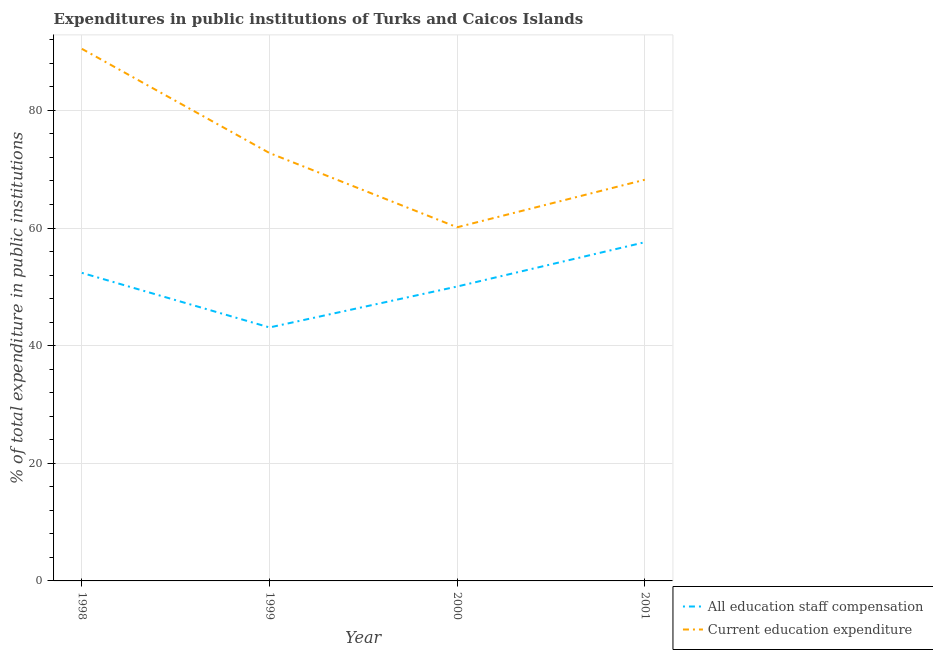How many different coloured lines are there?
Offer a terse response. 2. Is the number of lines equal to the number of legend labels?
Make the answer very short. Yes. What is the expenditure in staff compensation in 2000?
Provide a short and direct response. 50.06. Across all years, what is the maximum expenditure in education?
Provide a short and direct response. 90.48. Across all years, what is the minimum expenditure in education?
Offer a very short reply. 60.13. What is the total expenditure in staff compensation in the graph?
Make the answer very short. 203.12. What is the difference between the expenditure in staff compensation in 1998 and that in 2000?
Provide a short and direct response. 2.32. What is the difference between the expenditure in education in 1998 and the expenditure in staff compensation in 2000?
Keep it short and to the point. 40.42. What is the average expenditure in education per year?
Your response must be concise. 72.89. In the year 1998, what is the difference between the expenditure in staff compensation and expenditure in education?
Provide a succinct answer. -38.1. In how many years, is the expenditure in staff compensation greater than 28 %?
Your answer should be compact. 4. What is the ratio of the expenditure in staff compensation in 1998 to that in 1999?
Your answer should be very brief. 1.22. What is the difference between the highest and the second highest expenditure in staff compensation?
Offer a terse response. 5.21. What is the difference between the highest and the lowest expenditure in education?
Your answer should be very brief. 30.35. In how many years, is the expenditure in staff compensation greater than the average expenditure in staff compensation taken over all years?
Keep it short and to the point. 2. Is the sum of the expenditure in staff compensation in 2000 and 2001 greater than the maximum expenditure in education across all years?
Offer a terse response. Yes. Is the expenditure in education strictly greater than the expenditure in staff compensation over the years?
Offer a very short reply. Yes. Is the expenditure in education strictly less than the expenditure in staff compensation over the years?
Your answer should be very brief. No. How many lines are there?
Provide a short and direct response. 2. How many years are there in the graph?
Ensure brevity in your answer.  4. Are the values on the major ticks of Y-axis written in scientific E-notation?
Provide a short and direct response. No. Where does the legend appear in the graph?
Offer a terse response. Bottom right. How are the legend labels stacked?
Provide a short and direct response. Vertical. What is the title of the graph?
Your answer should be compact. Expenditures in public institutions of Turks and Caicos Islands. Does "Enforce a contract" appear as one of the legend labels in the graph?
Ensure brevity in your answer.  No. What is the label or title of the Y-axis?
Provide a short and direct response. % of total expenditure in public institutions. What is the % of total expenditure in public institutions of All education staff compensation in 1998?
Your answer should be compact. 52.38. What is the % of total expenditure in public institutions in Current education expenditure in 1998?
Your response must be concise. 90.48. What is the % of total expenditure in public institutions in All education staff compensation in 1999?
Provide a short and direct response. 43.1. What is the % of total expenditure in public institutions in Current education expenditure in 1999?
Keep it short and to the point. 72.75. What is the % of total expenditure in public institutions of All education staff compensation in 2000?
Provide a short and direct response. 50.06. What is the % of total expenditure in public institutions of Current education expenditure in 2000?
Your response must be concise. 60.13. What is the % of total expenditure in public institutions in All education staff compensation in 2001?
Your response must be concise. 57.59. What is the % of total expenditure in public institutions in Current education expenditure in 2001?
Ensure brevity in your answer.  68.21. Across all years, what is the maximum % of total expenditure in public institutions in All education staff compensation?
Your response must be concise. 57.59. Across all years, what is the maximum % of total expenditure in public institutions in Current education expenditure?
Make the answer very short. 90.48. Across all years, what is the minimum % of total expenditure in public institutions of All education staff compensation?
Offer a very short reply. 43.1. Across all years, what is the minimum % of total expenditure in public institutions of Current education expenditure?
Keep it short and to the point. 60.13. What is the total % of total expenditure in public institutions in All education staff compensation in the graph?
Your answer should be compact. 203.12. What is the total % of total expenditure in public institutions of Current education expenditure in the graph?
Your response must be concise. 291.57. What is the difference between the % of total expenditure in public institutions of All education staff compensation in 1998 and that in 1999?
Give a very brief answer. 9.28. What is the difference between the % of total expenditure in public institutions in Current education expenditure in 1998 and that in 1999?
Make the answer very short. 17.72. What is the difference between the % of total expenditure in public institutions in All education staff compensation in 1998 and that in 2000?
Your answer should be compact. 2.32. What is the difference between the % of total expenditure in public institutions in Current education expenditure in 1998 and that in 2000?
Offer a very short reply. 30.35. What is the difference between the % of total expenditure in public institutions in All education staff compensation in 1998 and that in 2001?
Make the answer very short. -5.21. What is the difference between the % of total expenditure in public institutions of Current education expenditure in 1998 and that in 2001?
Offer a terse response. 22.26. What is the difference between the % of total expenditure in public institutions in All education staff compensation in 1999 and that in 2000?
Your answer should be very brief. -6.96. What is the difference between the % of total expenditure in public institutions in Current education expenditure in 1999 and that in 2000?
Your response must be concise. 12.62. What is the difference between the % of total expenditure in public institutions in All education staff compensation in 1999 and that in 2001?
Your response must be concise. -14.49. What is the difference between the % of total expenditure in public institutions of Current education expenditure in 1999 and that in 2001?
Make the answer very short. 4.54. What is the difference between the % of total expenditure in public institutions of All education staff compensation in 2000 and that in 2001?
Make the answer very short. -7.53. What is the difference between the % of total expenditure in public institutions of Current education expenditure in 2000 and that in 2001?
Offer a terse response. -8.08. What is the difference between the % of total expenditure in public institutions in All education staff compensation in 1998 and the % of total expenditure in public institutions in Current education expenditure in 1999?
Provide a succinct answer. -20.37. What is the difference between the % of total expenditure in public institutions in All education staff compensation in 1998 and the % of total expenditure in public institutions in Current education expenditure in 2000?
Make the answer very short. -7.75. What is the difference between the % of total expenditure in public institutions of All education staff compensation in 1998 and the % of total expenditure in public institutions of Current education expenditure in 2001?
Offer a very short reply. -15.83. What is the difference between the % of total expenditure in public institutions of All education staff compensation in 1999 and the % of total expenditure in public institutions of Current education expenditure in 2000?
Make the answer very short. -17.03. What is the difference between the % of total expenditure in public institutions of All education staff compensation in 1999 and the % of total expenditure in public institutions of Current education expenditure in 2001?
Give a very brief answer. -25.12. What is the difference between the % of total expenditure in public institutions in All education staff compensation in 2000 and the % of total expenditure in public institutions in Current education expenditure in 2001?
Provide a short and direct response. -18.15. What is the average % of total expenditure in public institutions of All education staff compensation per year?
Give a very brief answer. 50.78. What is the average % of total expenditure in public institutions of Current education expenditure per year?
Make the answer very short. 72.89. In the year 1998, what is the difference between the % of total expenditure in public institutions in All education staff compensation and % of total expenditure in public institutions in Current education expenditure?
Offer a terse response. -38.1. In the year 1999, what is the difference between the % of total expenditure in public institutions of All education staff compensation and % of total expenditure in public institutions of Current education expenditure?
Make the answer very short. -29.66. In the year 2000, what is the difference between the % of total expenditure in public institutions of All education staff compensation and % of total expenditure in public institutions of Current education expenditure?
Your response must be concise. -10.07. In the year 2001, what is the difference between the % of total expenditure in public institutions of All education staff compensation and % of total expenditure in public institutions of Current education expenditure?
Your answer should be very brief. -10.63. What is the ratio of the % of total expenditure in public institutions in All education staff compensation in 1998 to that in 1999?
Offer a terse response. 1.22. What is the ratio of the % of total expenditure in public institutions of Current education expenditure in 1998 to that in 1999?
Keep it short and to the point. 1.24. What is the ratio of the % of total expenditure in public institutions of All education staff compensation in 1998 to that in 2000?
Your answer should be very brief. 1.05. What is the ratio of the % of total expenditure in public institutions in Current education expenditure in 1998 to that in 2000?
Offer a terse response. 1.5. What is the ratio of the % of total expenditure in public institutions of All education staff compensation in 1998 to that in 2001?
Provide a short and direct response. 0.91. What is the ratio of the % of total expenditure in public institutions of Current education expenditure in 1998 to that in 2001?
Ensure brevity in your answer.  1.33. What is the ratio of the % of total expenditure in public institutions of All education staff compensation in 1999 to that in 2000?
Make the answer very short. 0.86. What is the ratio of the % of total expenditure in public institutions of Current education expenditure in 1999 to that in 2000?
Offer a terse response. 1.21. What is the ratio of the % of total expenditure in public institutions of All education staff compensation in 1999 to that in 2001?
Ensure brevity in your answer.  0.75. What is the ratio of the % of total expenditure in public institutions of Current education expenditure in 1999 to that in 2001?
Ensure brevity in your answer.  1.07. What is the ratio of the % of total expenditure in public institutions in All education staff compensation in 2000 to that in 2001?
Your answer should be compact. 0.87. What is the ratio of the % of total expenditure in public institutions in Current education expenditure in 2000 to that in 2001?
Your answer should be very brief. 0.88. What is the difference between the highest and the second highest % of total expenditure in public institutions in All education staff compensation?
Offer a terse response. 5.21. What is the difference between the highest and the second highest % of total expenditure in public institutions in Current education expenditure?
Give a very brief answer. 17.72. What is the difference between the highest and the lowest % of total expenditure in public institutions in All education staff compensation?
Provide a short and direct response. 14.49. What is the difference between the highest and the lowest % of total expenditure in public institutions in Current education expenditure?
Your response must be concise. 30.35. 